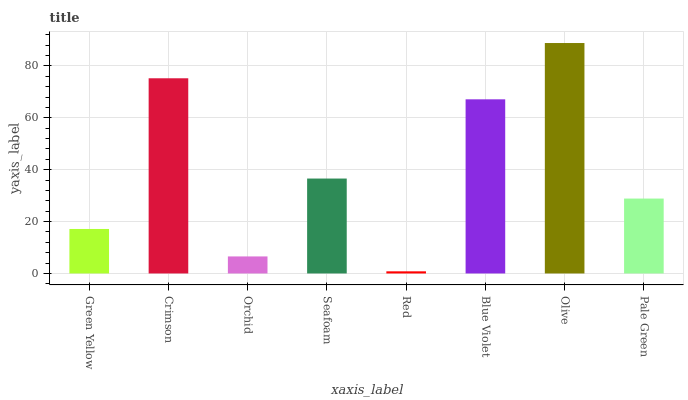Is Red the minimum?
Answer yes or no. Yes. Is Olive the maximum?
Answer yes or no. Yes. Is Crimson the minimum?
Answer yes or no. No. Is Crimson the maximum?
Answer yes or no. No. Is Crimson greater than Green Yellow?
Answer yes or no. Yes. Is Green Yellow less than Crimson?
Answer yes or no. Yes. Is Green Yellow greater than Crimson?
Answer yes or no. No. Is Crimson less than Green Yellow?
Answer yes or no. No. Is Seafoam the high median?
Answer yes or no. Yes. Is Pale Green the low median?
Answer yes or no. Yes. Is Orchid the high median?
Answer yes or no. No. Is Olive the low median?
Answer yes or no. No. 